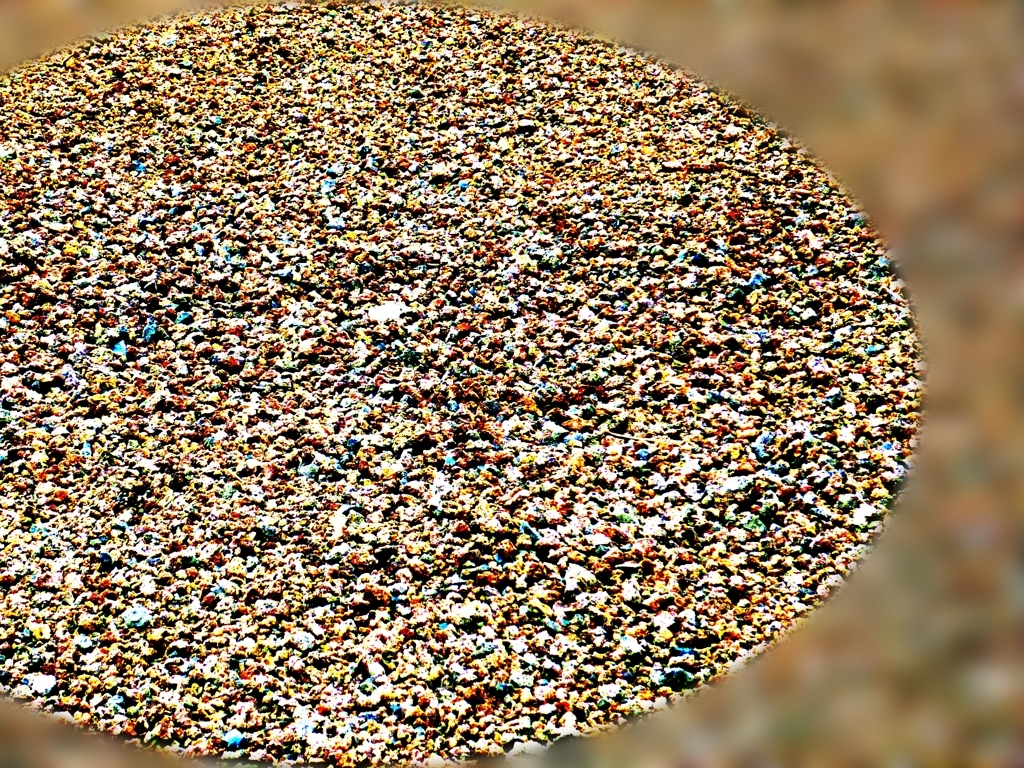What could this image possibly represent? The image appears to be an abstract representation, potentially a bird's-eye view of a crowded area or a collection of objects with varied colors and shapes that create a mosaic effect. The patterns are irregular and densely packed, evoking a sense of complexity or chaos. 